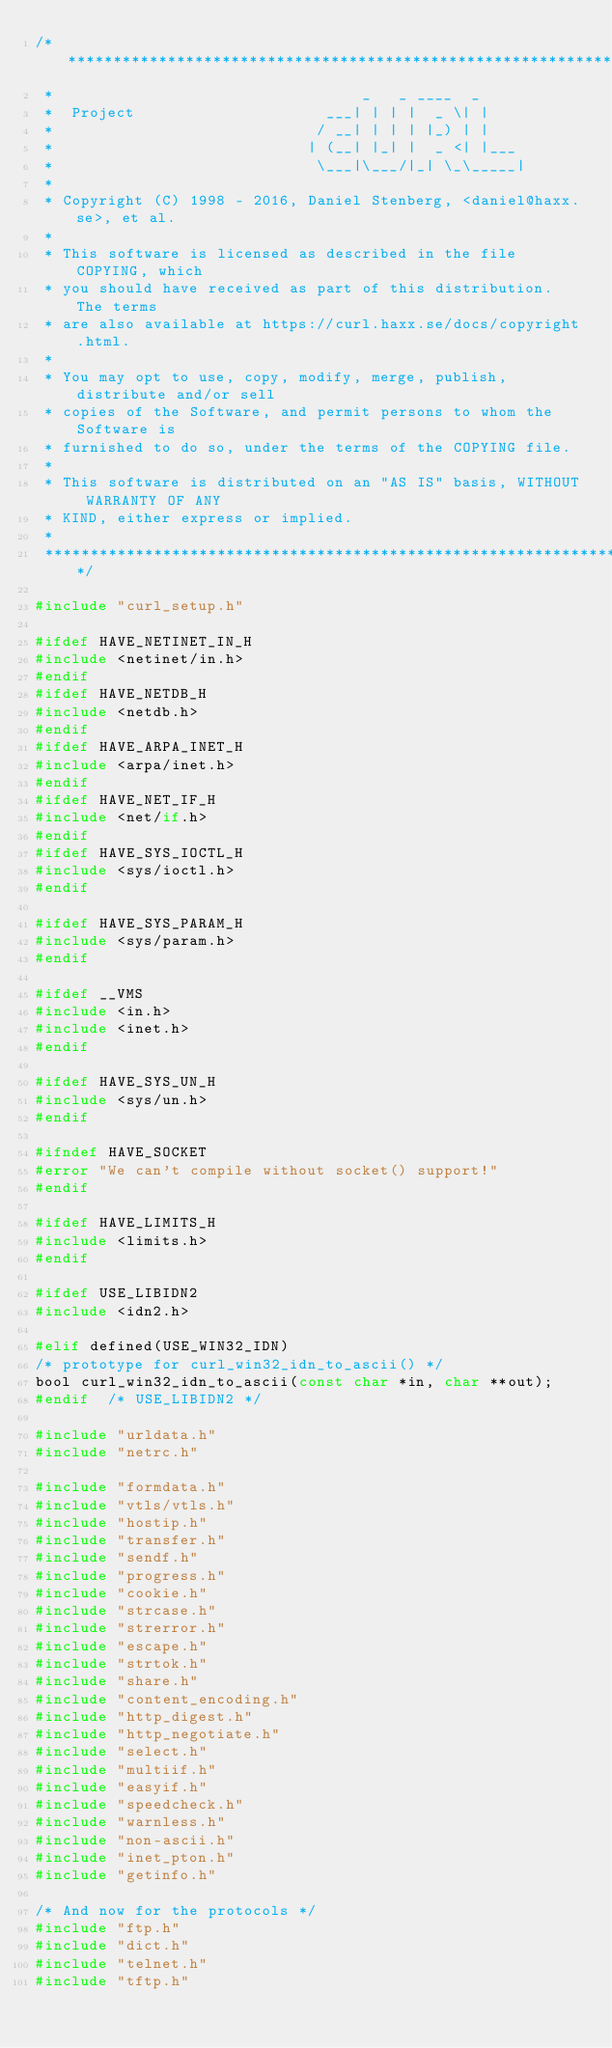<code> <loc_0><loc_0><loc_500><loc_500><_C_>/***************************************************************************
 *                                  _   _ ____  _
 *  Project                     ___| | | |  _ \| |
 *                             / __| | | | |_) | |
 *                            | (__| |_| |  _ <| |___
 *                             \___|\___/|_| \_\_____|
 *
 * Copyright (C) 1998 - 2016, Daniel Stenberg, <daniel@haxx.se>, et al.
 *
 * This software is licensed as described in the file COPYING, which
 * you should have received as part of this distribution. The terms
 * are also available at https://curl.haxx.se/docs/copyright.html.
 *
 * You may opt to use, copy, modify, merge, publish, distribute and/or sell
 * copies of the Software, and permit persons to whom the Software is
 * furnished to do so, under the terms of the COPYING file.
 *
 * This software is distributed on an "AS IS" basis, WITHOUT WARRANTY OF ANY
 * KIND, either express or implied.
 *
 ***************************************************************************/

#include "curl_setup.h"

#ifdef HAVE_NETINET_IN_H
#include <netinet/in.h>
#endif
#ifdef HAVE_NETDB_H
#include <netdb.h>
#endif
#ifdef HAVE_ARPA_INET_H
#include <arpa/inet.h>
#endif
#ifdef HAVE_NET_IF_H
#include <net/if.h>
#endif
#ifdef HAVE_SYS_IOCTL_H
#include <sys/ioctl.h>
#endif

#ifdef HAVE_SYS_PARAM_H
#include <sys/param.h>
#endif

#ifdef __VMS
#include <in.h>
#include <inet.h>
#endif

#ifdef HAVE_SYS_UN_H
#include <sys/un.h>
#endif

#ifndef HAVE_SOCKET
#error "We can't compile without socket() support!"
#endif

#ifdef HAVE_LIMITS_H
#include <limits.h>
#endif

#ifdef USE_LIBIDN2
#include <idn2.h>

#elif defined(USE_WIN32_IDN)
/* prototype for curl_win32_idn_to_ascii() */
bool curl_win32_idn_to_ascii(const char *in, char **out);
#endif  /* USE_LIBIDN2 */

#include "urldata.h"
#include "netrc.h"

#include "formdata.h"
#include "vtls/vtls.h"
#include "hostip.h"
#include "transfer.h"
#include "sendf.h"
#include "progress.h"
#include "cookie.h"
#include "strcase.h"
#include "strerror.h"
#include "escape.h"
#include "strtok.h"
#include "share.h"
#include "content_encoding.h"
#include "http_digest.h"
#include "http_negotiate.h"
#include "select.h"
#include "multiif.h"
#include "easyif.h"
#include "speedcheck.h"
#include "warnless.h"
#include "non-ascii.h"
#include "inet_pton.h"
#include "getinfo.h"

/* And now for the protocols */
#include "ftp.h"
#include "dict.h"
#include "telnet.h"
#include "tftp.h"</code> 